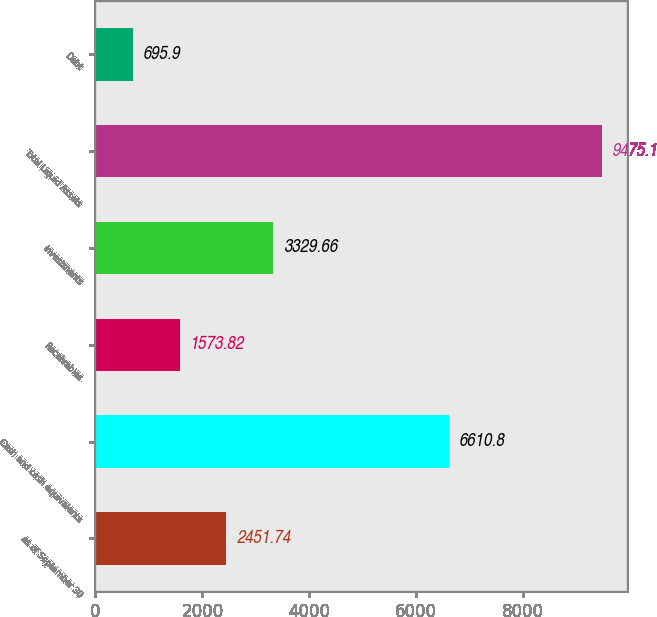Convert chart to OTSL. <chart><loc_0><loc_0><loc_500><loc_500><bar_chart><fcel>as of September 30<fcel>Cash and cash equivalents<fcel>Receivables<fcel>Investments<fcel>Total Liquid Assets<fcel>Debt<nl><fcel>2451.74<fcel>6610.8<fcel>1573.82<fcel>3329.66<fcel>9475.1<fcel>695.9<nl></chart> 